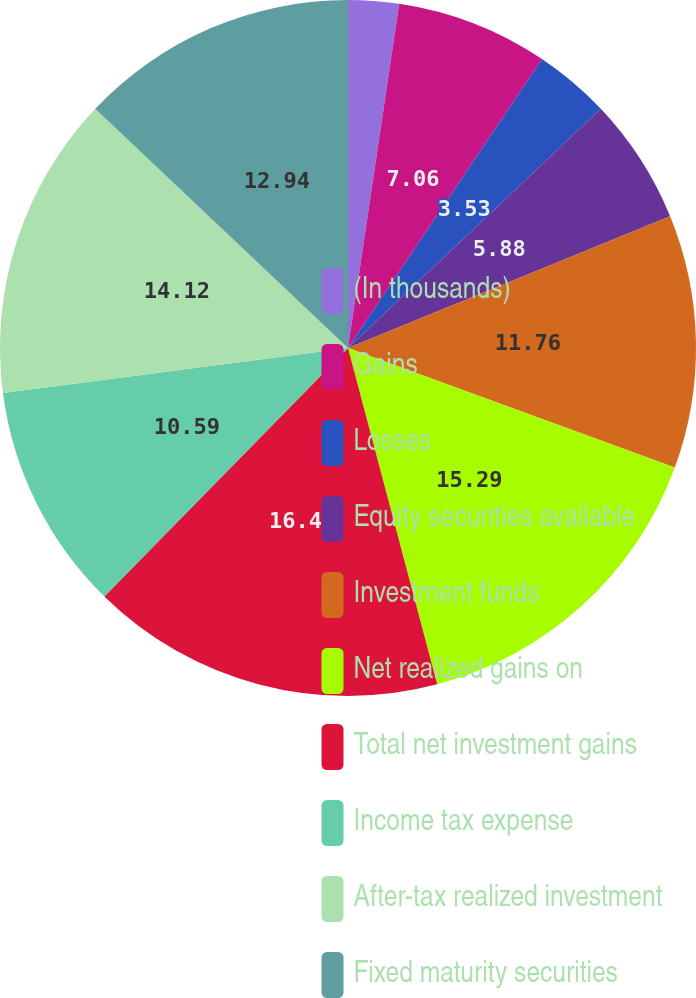<chart> <loc_0><loc_0><loc_500><loc_500><pie_chart><fcel>(In thousands)<fcel>Gains<fcel>Losses<fcel>Equity securities available<fcel>Investment funds<fcel>Net realized gains on<fcel>Total net investment gains<fcel>Income tax expense<fcel>After-tax realized investment<fcel>Fixed maturity securities<nl><fcel>2.35%<fcel>7.06%<fcel>3.53%<fcel>5.88%<fcel>11.76%<fcel>15.29%<fcel>16.47%<fcel>10.59%<fcel>14.12%<fcel>12.94%<nl></chart> 